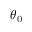Convert formula to latex. <formula><loc_0><loc_0><loc_500><loc_500>\theta _ { 0 }</formula> 